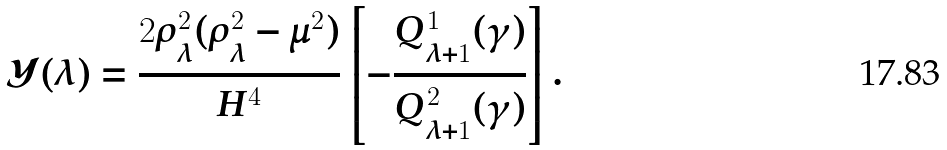<formula> <loc_0><loc_0><loc_500><loc_500>\mathcal { Y } ( \lambda ) = \frac { 2 \rho _ { \lambda } ^ { 2 } ( \rho _ { \lambda } ^ { 2 } - \mu ^ { 2 } ) } { H ^ { 4 } } \left [ - \frac { Q _ { \lambda + 1 } ^ { 1 } ( \gamma ) } { Q _ { \lambda + 1 } ^ { 2 } ( \gamma ) } \right ] .</formula> 